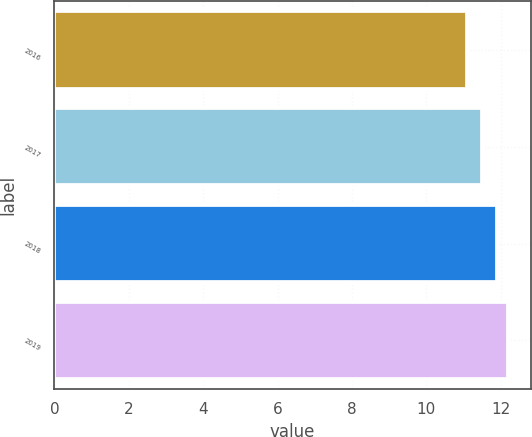Convert chart to OTSL. <chart><loc_0><loc_0><loc_500><loc_500><bar_chart><fcel>2016<fcel>2017<fcel>2018<fcel>2019<nl><fcel>11.1<fcel>11.5<fcel>11.9<fcel>12.2<nl></chart> 